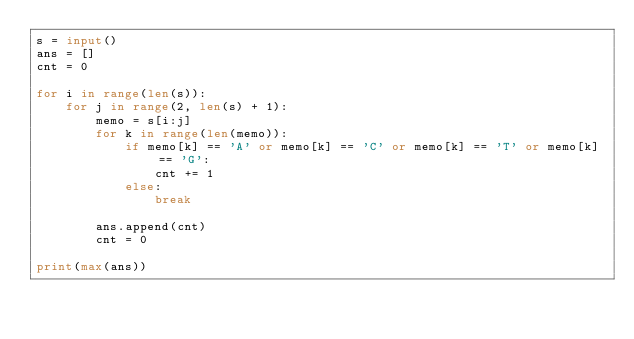Convert code to text. <code><loc_0><loc_0><loc_500><loc_500><_Python_>s = input()
ans = []
cnt = 0

for i in range(len(s)):
    for j in range(2, len(s) + 1):
        memo = s[i:j]
        for k in range(len(memo)):
            if memo[k] == 'A' or memo[k] == 'C' or memo[k] == 'T' or memo[k] == 'G':
                cnt += 1
            else:
                break

        ans.append(cnt)
        cnt = 0

print(max(ans))
</code> 